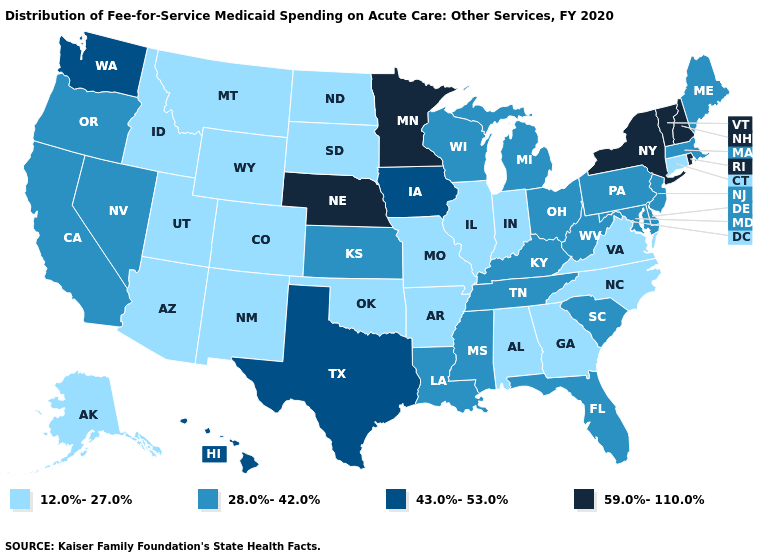Name the states that have a value in the range 28.0%-42.0%?
Answer briefly. California, Delaware, Florida, Kansas, Kentucky, Louisiana, Maine, Maryland, Massachusetts, Michigan, Mississippi, Nevada, New Jersey, Ohio, Oregon, Pennsylvania, South Carolina, Tennessee, West Virginia, Wisconsin. Does Missouri have the lowest value in the USA?
Answer briefly. Yes. What is the value of Connecticut?
Keep it brief. 12.0%-27.0%. What is the highest value in the West ?
Give a very brief answer. 43.0%-53.0%. What is the highest value in states that border Massachusetts?
Quick response, please. 59.0%-110.0%. What is the value of Iowa?
Concise answer only. 43.0%-53.0%. Name the states that have a value in the range 12.0%-27.0%?
Give a very brief answer. Alabama, Alaska, Arizona, Arkansas, Colorado, Connecticut, Georgia, Idaho, Illinois, Indiana, Missouri, Montana, New Mexico, North Carolina, North Dakota, Oklahoma, South Dakota, Utah, Virginia, Wyoming. What is the value of New Hampshire?
Give a very brief answer. 59.0%-110.0%. Which states hav the highest value in the MidWest?
Write a very short answer. Minnesota, Nebraska. Does Connecticut have a lower value than New York?
Answer briefly. Yes. Which states have the lowest value in the USA?
Quick response, please. Alabama, Alaska, Arizona, Arkansas, Colorado, Connecticut, Georgia, Idaho, Illinois, Indiana, Missouri, Montana, New Mexico, North Carolina, North Dakota, Oklahoma, South Dakota, Utah, Virginia, Wyoming. Does Washington have the lowest value in the West?
Keep it brief. No. What is the value of Indiana?
Answer briefly. 12.0%-27.0%. What is the value of Massachusetts?
Answer briefly. 28.0%-42.0%. What is the value of Ohio?
Answer briefly. 28.0%-42.0%. 